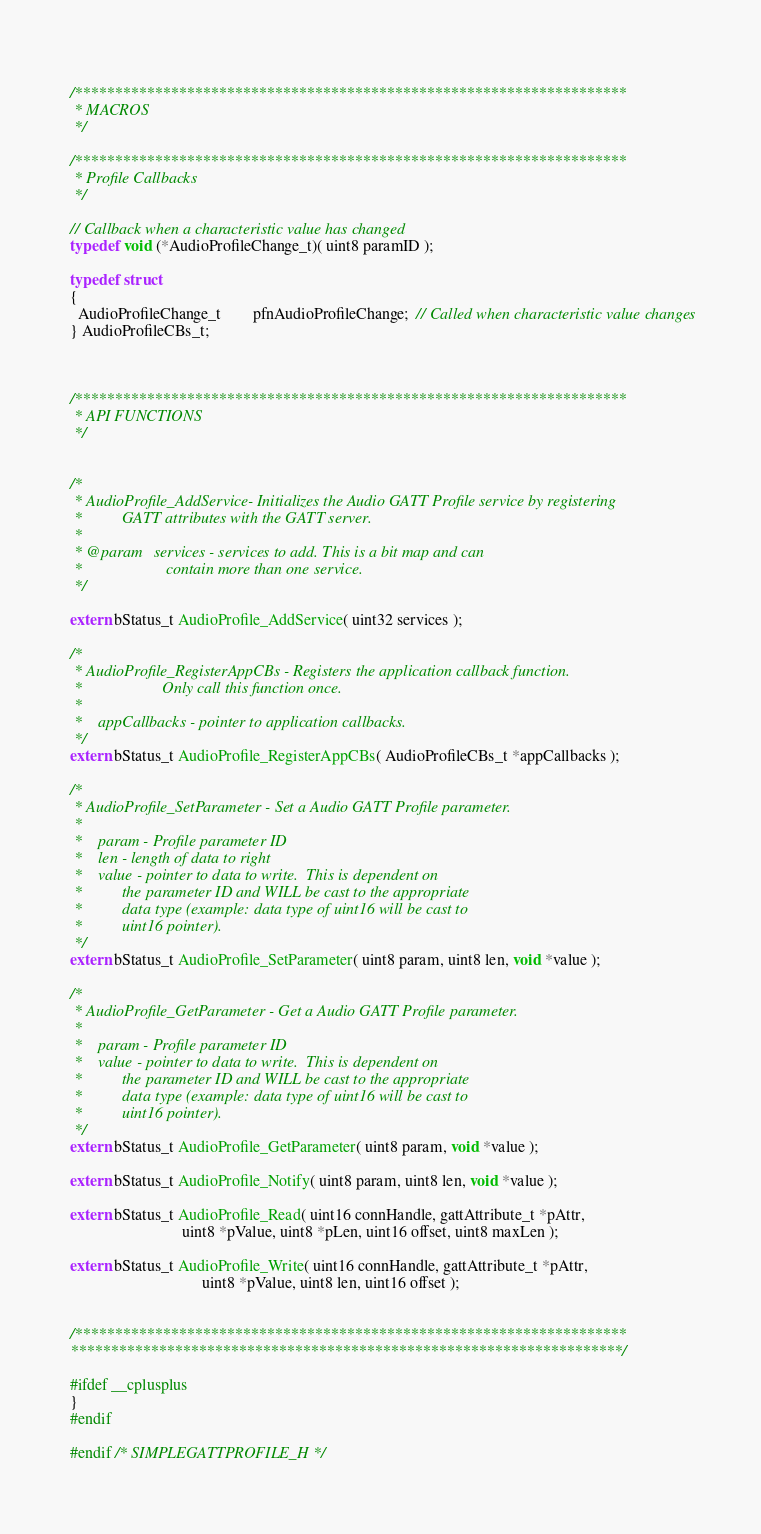<code> <loc_0><loc_0><loc_500><loc_500><_C_>
  
/*********************************************************************
 * MACROS
 */

/*********************************************************************
 * Profile Callbacks
 */

// Callback when a characteristic value has changed
typedef void (*AudioProfileChange_t)( uint8 paramID );

typedef struct
{
  AudioProfileChange_t        pfnAudioProfileChange;  // Called when characteristic value changes
} AudioProfileCBs_t;

    

/*********************************************************************
 * API FUNCTIONS 
 */


/*
 * AudioProfile_AddService- Initializes the Audio GATT Profile service by registering
 *          GATT attributes with the GATT server.
 *
 * @param   services - services to add. This is a bit map and can
 *                     contain more than one service.
 */

extern bStatus_t AudioProfile_AddService( uint32 services );

/*
 * AudioProfile_RegisterAppCBs - Registers the application callback function.
 *                    Only call this function once.
 *
 *    appCallbacks - pointer to application callbacks.
 */
extern bStatus_t AudioProfile_RegisterAppCBs( AudioProfileCBs_t *appCallbacks );

/*
 * AudioProfile_SetParameter - Set a Audio GATT Profile parameter.
 *
 *    param - Profile parameter ID
 *    len - length of data to right
 *    value - pointer to data to write.  This is dependent on
 *          the parameter ID and WILL be cast to the appropriate 
 *          data type (example: data type of uint16 will be cast to 
 *          uint16 pointer).
 */
extern bStatus_t AudioProfile_SetParameter( uint8 param, uint8 len, void *value );
  
/*
 * AudioProfile_GetParameter - Get a Audio GATT Profile parameter.
 *
 *    param - Profile parameter ID
 *    value - pointer to data to write.  This is dependent on
 *          the parameter ID and WILL be cast to the appropriate 
 *          data type (example: data type of uint16 will be cast to 
 *          uint16 pointer).
 */
extern bStatus_t AudioProfile_GetParameter( uint8 param, void *value );

extern bStatus_t AudioProfile_Notify( uint8 param, uint8 len, void *value );

extern bStatus_t AudioProfile_Read( uint16 connHandle, gattAttribute_t *pAttr, 
                            uint8 *pValue, uint8 *pLen, uint16 offset, uint8 maxLen );

extern bStatus_t AudioProfile_Write( uint16 connHandle, gattAttribute_t *pAttr,
                                 uint8 *pValue, uint8 len, uint16 offset );


/*********************************************************************
*********************************************************************/

#ifdef __cplusplus
}
#endif

#endif /* SIMPLEGATTPROFILE_H */
</code> 